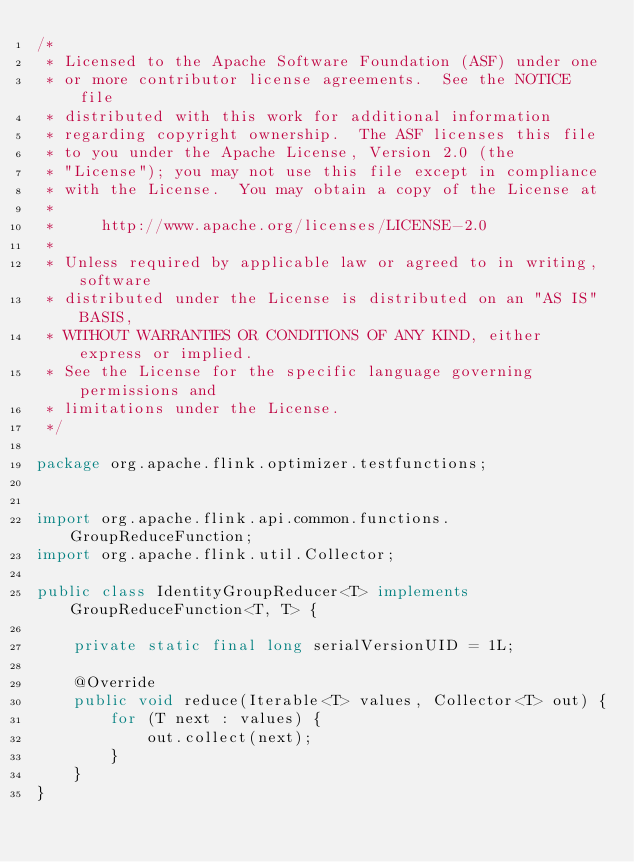<code> <loc_0><loc_0><loc_500><loc_500><_Java_>/*
 * Licensed to the Apache Software Foundation (ASF) under one
 * or more contributor license agreements.  See the NOTICE file
 * distributed with this work for additional information
 * regarding copyright ownership.  The ASF licenses this file
 * to you under the Apache License, Version 2.0 (the
 * "License"); you may not use this file except in compliance
 * with the License.  You may obtain a copy of the License at
 *
 *     http://www.apache.org/licenses/LICENSE-2.0
 *
 * Unless required by applicable law or agreed to in writing, software
 * distributed under the License is distributed on an "AS IS" BASIS,
 * WITHOUT WARRANTIES OR CONDITIONS OF ANY KIND, either express or implied.
 * See the License for the specific language governing permissions and
 * limitations under the License.
 */

package org.apache.flink.optimizer.testfunctions;


import org.apache.flink.api.common.functions.GroupReduceFunction;
import org.apache.flink.util.Collector;

public class IdentityGroupReducer<T> implements GroupReduceFunction<T, T> {

	private static final long serialVersionUID = 1L;

	@Override
	public void reduce(Iterable<T> values, Collector<T> out) {
		for (T next : values) {
			out.collect(next);
		}
	}
}
</code> 